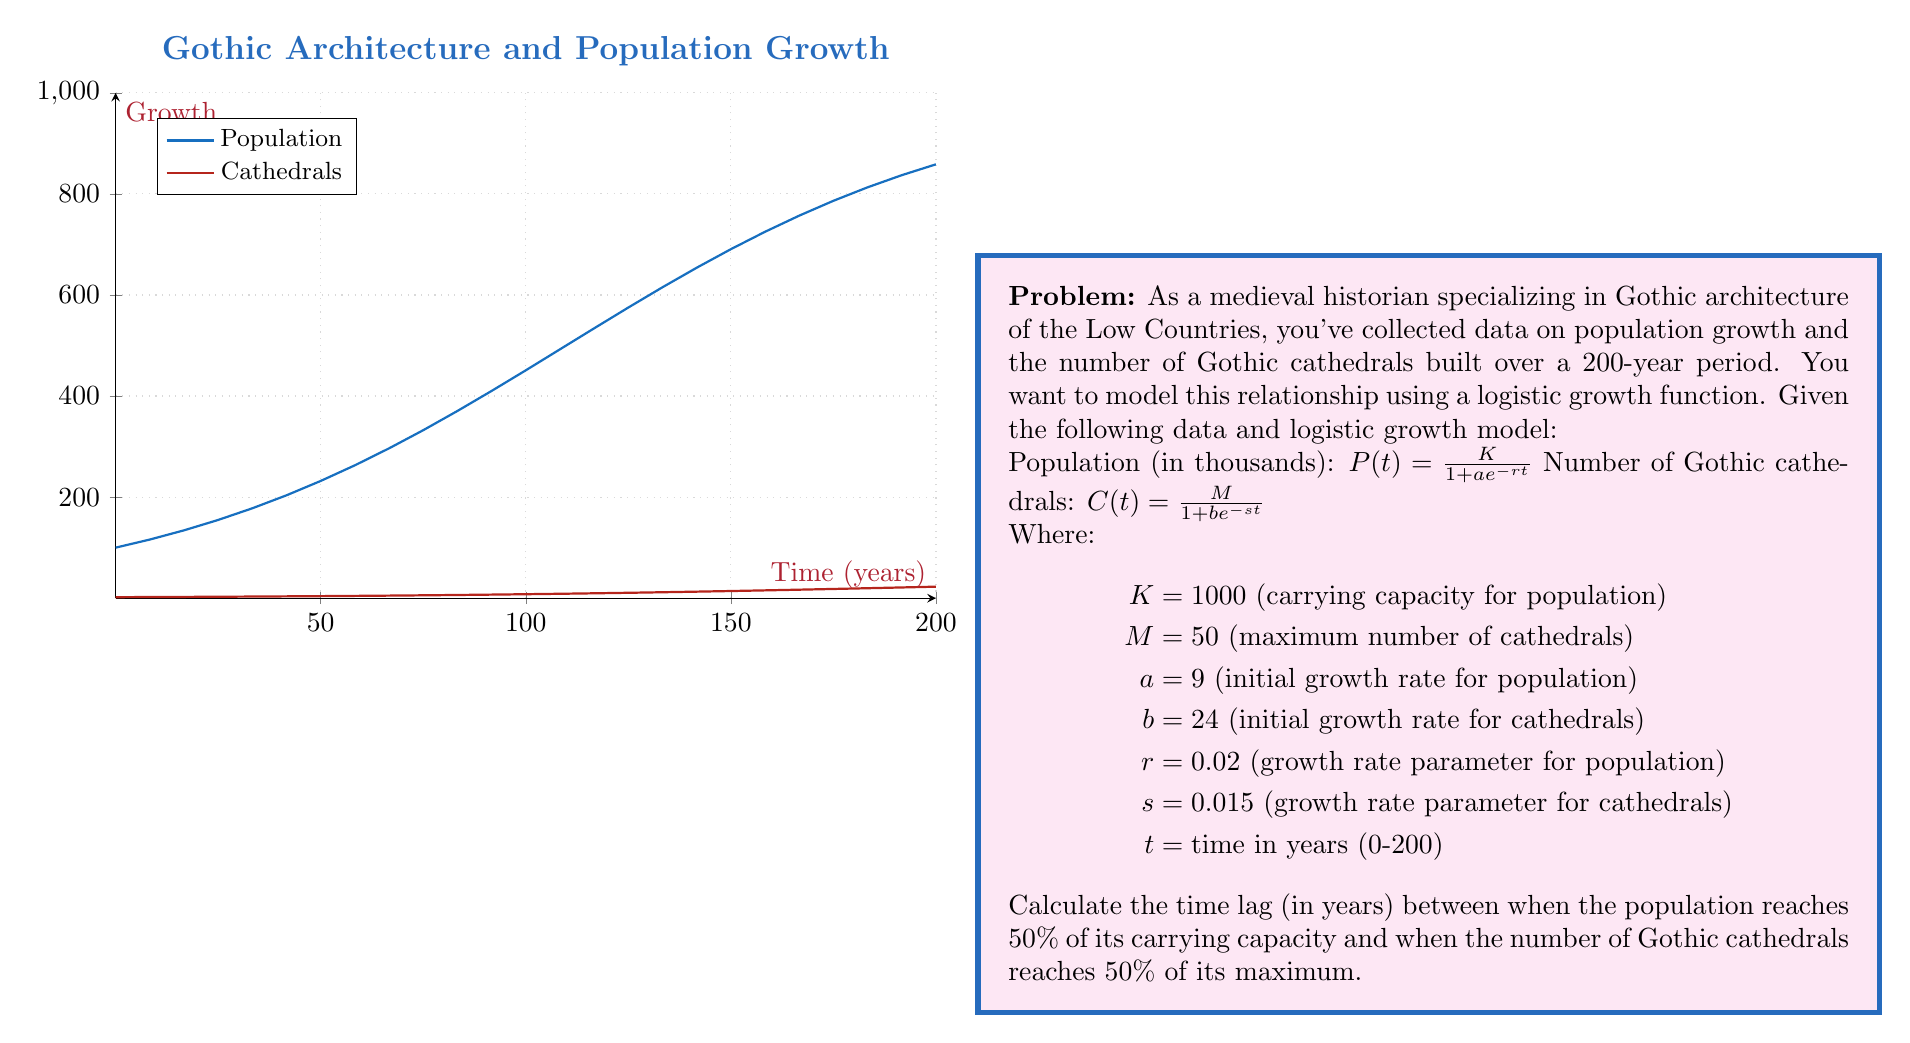Could you help me with this problem? To solve this problem, we need to follow these steps:

1) First, we need to find when the population reaches 50% of its carrying capacity. This occurs when $P(t) = 500$.

2) We can set up the equation:

   $500 = \frac{1000}{1 + 9e^{-0.02t}}$

3) Solving for $t$:
   
   $1 + 9e^{-0.02t} = 2$
   $9e^{-0.02t} = 1$
   $e^{-0.02t} = \frac{1}{9}$
   $-0.02t = \ln(\frac{1}{9})$
   $t = -\frac{\ln(\frac{1}{9})}{0.02} \approx 110.23$ years

4) Next, we need to find when the number of cathedrals reaches 50% of its maximum. This occurs when $C(t) = 25$.

5) We can set up the equation:

   $25 = \frac{50}{1 + 24e^{-0.015t}}$

6) Solving for $t$:

   $1 + 24e^{-0.015t} = 2$
   $24e^{-0.015t} = 1$
   $e^{-0.015t} = \frac{1}{24}$
   $-0.015t = \ln(\frac{1}{24})$
   $t = -\frac{\ln(\frac{1}{24})}{0.015} \approx 211.39$ years

7) The time lag is the difference between these two times:

   $211.39 - 110.23 \approx 101.16$ years
Answer: 101.16 years 